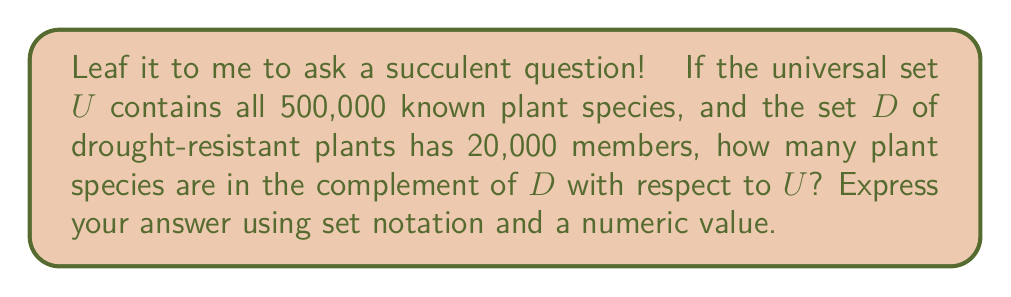Can you answer this question? Let's break this down step by step:

1) First, let's define our sets:
   $U$ = Universal set of all plants
   $D$ = Set of drought-resistant plants

2) We're given that:
   $|U| = 500,000$ (total number of plant species)
   $|D| = 20,000$ (number of drought-resistant plant species)

3) The complement of set $D$ with respect to $U$, denoted as $D^c$ or $U \setminus D$, is the set of all elements in $U$ that are not in $D$.

4) To find the number of elements in $D^c$, we can use the following formula:
   $|D^c| = |U| - |D|$

5) Substituting our known values:
   $|D^c| = 500,000 - 20,000 = 480,000$

6) Therefore, there are 480,000 plant species that are not drought-resistant.

7) In set notation, we can express this as:
   $D^c = U \setminus D = \{x \in U : x \notin D\}$
   $|D^c| = 480,000$

This result shows that the vast majority of plant species are not classified as drought-resistant. It's like nature's way of saying, "Water you waiting for? Conserve water!"
Answer: $D^c = U \setminus D = \{x \in U : x \notin D\}$, where $|D^c| = 480,000$ 